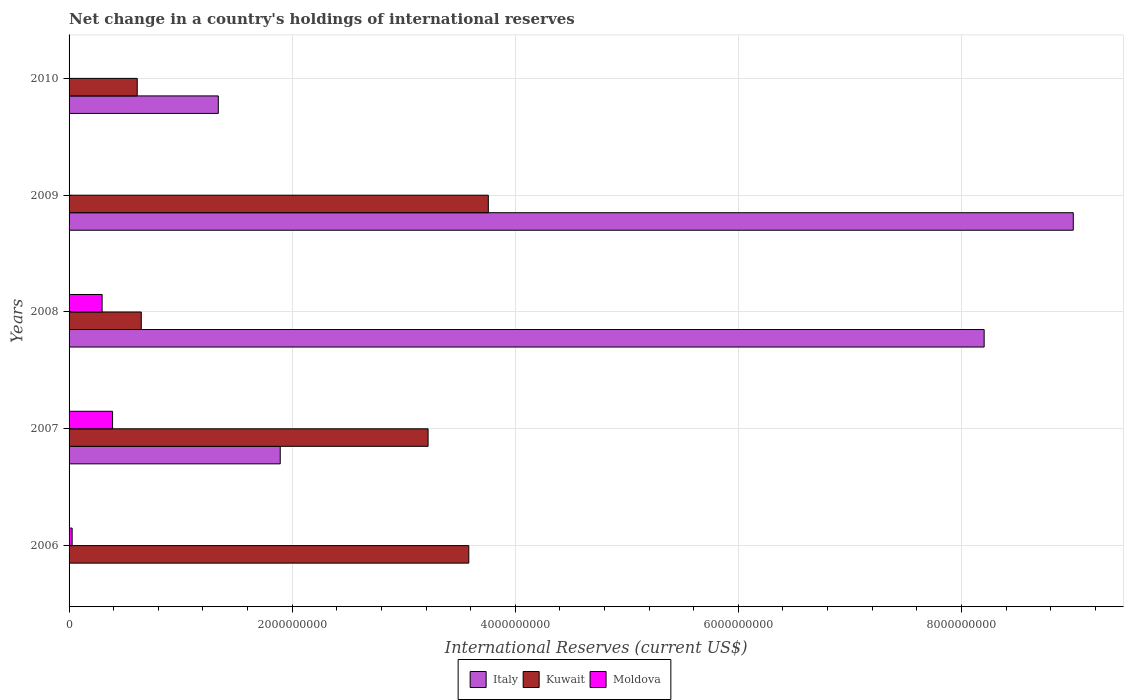How many different coloured bars are there?
Give a very brief answer. 3. How many groups of bars are there?
Offer a very short reply. 5. Are the number of bars per tick equal to the number of legend labels?
Your answer should be very brief. No. How many bars are there on the 3rd tick from the top?
Your response must be concise. 3. How many bars are there on the 1st tick from the bottom?
Ensure brevity in your answer.  2. What is the international reserves in Italy in 2010?
Your answer should be compact. 1.34e+09. Across all years, what is the maximum international reserves in Kuwait?
Your response must be concise. 3.76e+09. Across all years, what is the minimum international reserves in Italy?
Offer a very short reply. 0. In which year was the international reserves in Moldova maximum?
Offer a terse response. 2007. What is the total international reserves in Moldova in the graph?
Provide a short and direct response. 7.14e+08. What is the difference between the international reserves in Kuwait in 2006 and that in 2007?
Keep it short and to the point. 3.65e+08. What is the difference between the international reserves in Kuwait in 2010 and the international reserves in Italy in 2009?
Make the answer very short. -8.39e+09. What is the average international reserves in Kuwait per year?
Provide a short and direct response. 2.36e+09. In the year 2007, what is the difference between the international reserves in Kuwait and international reserves in Moldova?
Your answer should be compact. 2.83e+09. In how many years, is the international reserves in Kuwait greater than 1200000000 US$?
Offer a terse response. 3. What is the ratio of the international reserves in Italy in 2007 to that in 2010?
Give a very brief answer. 1.41. What is the difference between the highest and the second highest international reserves in Kuwait?
Ensure brevity in your answer.  1.75e+08. What is the difference between the highest and the lowest international reserves in Kuwait?
Provide a short and direct response. 3.15e+09. Is it the case that in every year, the sum of the international reserves in Moldova and international reserves in Italy is greater than the international reserves in Kuwait?
Your answer should be compact. No. How many bars are there?
Keep it short and to the point. 12. Are all the bars in the graph horizontal?
Ensure brevity in your answer.  Yes. What is the difference between two consecutive major ticks on the X-axis?
Give a very brief answer. 2.00e+09. Are the values on the major ticks of X-axis written in scientific E-notation?
Provide a succinct answer. No. Does the graph contain grids?
Make the answer very short. Yes. Where does the legend appear in the graph?
Make the answer very short. Bottom center. How are the legend labels stacked?
Offer a very short reply. Horizontal. What is the title of the graph?
Ensure brevity in your answer.  Net change in a country's holdings of international reserves. What is the label or title of the X-axis?
Offer a terse response. International Reserves (current US$). What is the label or title of the Y-axis?
Provide a succinct answer. Years. What is the International Reserves (current US$) in Italy in 2006?
Make the answer very short. 0. What is the International Reserves (current US$) of Kuwait in 2006?
Offer a very short reply. 3.58e+09. What is the International Reserves (current US$) of Moldova in 2006?
Provide a short and direct response. 2.75e+07. What is the International Reserves (current US$) in Italy in 2007?
Offer a very short reply. 1.89e+09. What is the International Reserves (current US$) of Kuwait in 2007?
Your answer should be compact. 3.22e+09. What is the International Reserves (current US$) in Moldova in 2007?
Your answer should be compact. 3.90e+08. What is the International Reserves (current US$) of Italy in 2008?
Give a very brief answer. 8.20e+09. What is the International Reserves (current US$) in Kuwait in 2008?
Give a very brief answer. 6.47e+08. What is the International Reserves (current US$) in Moldova in 2008?
Provide a succinct answer. 2.96e+08. What is the International Reserves (current US$) in Italy in 2009?
Your answer should be compact. 9.00e+09. What is the International Reserves (current US$) of Kuwait in 2009?
Offer a terse response. 3.76e+09. What is the International Reserves (current US$) of Italy in 2010?
Offer a very short reply. 1.34e+09. What is the International Reserves (current US$) of Kuwait in 2010?
Your response must be concise. 6.11e+08. What is the International Reserves (current US$) in Moldova in 2010?
Your response must be concise. 0. Across all years, what is the maximum International Reserves (current US$) of Italy?
Provide a succinct answer. 9.00e+09. Across all years, what is the maximum International Reserves (current US$) of Kuwait?
Give a very brief answer. 3.76e+09. Across all years, what is the maximum International Reserves (current US$) of Moldova?
Make the answer very short. 3.90e+08. Across all years, what is the minimum International Reserves (current US$) of Italy?
Ensure brevity in your answer.  0. Across all years, what is the minimum International Reserves (current US$) of Kuwait?
Offer a terse response. 6.11e+08. What is the total International Reserves (current US$) of Italy in the graph?
Offer a terse response. 2.04e+1. What is the total International Reserves (current US$) of Kuwait in the graph?
Give a very brief answer. 1.18e+1. What is the total International Reserves (current US$) of Moldova in the graph?
Offer a terse response. 7.14e+08. What is the difference between the International Reserves (current US$) of Kuwait in 2006 and that in 2007?
Make the answer very short. 3.65e+08. What is the difference between the International Reserves (current US$) in Moldova in 2006 and that in 2007?
Your answer should be very brief. -3.62e+08. What is the difference between the International Reserves (current US$) of Kuwait in 2006 and that in 2008?
Make the answer very short. 2.94e+09. What is the difference between the International Reserves (current US$) in Moldova in 2006 and that in 2008?
Provide a short and direct response. -2.69e+08. What is the difference between the International Reserves (current US$) in Kuwait in 2006 and that in 2009?
Offer a very short reply. -1.75e+08. What is the difference between the International Reserves (current US$) in Kuwait in 2006 and that in 2010?
Make the answer very short. 2.97e+09. What is the difference between the International Reserves (current US$) in Italy in 2007 and that in 2008?
Provide a succinct answer. -6.31e+09. What is the difference between the International Reserves (current US$) in Kuwait in 2007 and that in 2008?
Provide a short and direct response. 2.57e+09. What is the difference between the International Reserves (current US$) of Moldova in 2007 and that in 2008?
Keep it short and to the point. 9.37e+07. What is the difference between the International Reserves (current US$) in Italy in 2007 and that in 2009?
Keep it short and to the point. -7.11e+09. What is the difference between the International Reserves (current US$) of Kuwait in 2007 and that in 2009?
Give a very brief answer. -5.40e+08. What is the difference between the International Reserves (current US$) in Italy in 2007 and that in 2010?
Provide a short and direct response. 5.55e+08. What is the difference between the International Reserves (current US$) of Kuwait in 2007 and that in 2010?
Your answer should be very brief. 2.61e+09. What is the difference between the International Reserves (current US$) of Italy in 2008 and that in 2009?
Give a very brief answer. -7.99e+08. What is the difference between the International Reserves (current US$) of Kuwait in 2008 and that in 2009?
Your answer should be very brief. -3.11e+09. What is the difference between the International Reserves (current US$) in Italy in 2008 and that in 2010?
Provide a short and direct response. 6.87e+09. What is the difference between the International Reserves (current US$) of Kuwait in 2008 and that in 2010?
Offer a terse response. 3.63e+07. What is the difference between the International Reserves (current US$) in Italy in 2009 and that in 2010?
Provide a short and direct response. 7.66e+09. What is the difference between the International Reserves (current US$) of Kuwait in 2009 and that in 2010?
Ensure brevity in your answer.  3.15e+09. What is the difference between the International Reserves (current US$) of Kuwait in 2006 and the International Reserves (current US$) of Moldova in 2007?
Ensure brevity in your answer.  3.19e+09. What is the difference between the International Reserves (current US$) in Kuwait in 2006 and the International Reserves (current US$) in Moldova in 2008?
Your answer should be very brief. 3.29e+09. What is the difference between the International Reserves (current US$) in Italy in 2007 and the International Reserves (current US$) in Kuwait in 2008?
Your answer should be very brief. 1.25e+09. What is the difference between the International Reserves (current US$) in Italy in 2007 and the International Reserves (current US$) in Moldova in 2008?
Make the answer very short. 1.60e+09. What is the difference between the International Reserves (current US$) in Kuwait in 2007 and the International Reserves (current US$) in Moldova in 2008?
Provide a short and direct response. 2.92e+09. What is the difference between the International Reserves (current US$) in Italy in 2007 and the International Reserves (current US$) in Kuwait in 2009?
Make the answer very short. -1.87e+09. What is the difference between the International Reserves (current US$) of Italy in 2007 and the International Reserves (current US$) of Kuwait in 2010?
Your response must be concise. 1.28e+09. What is the difference between the International Reserves (current US$) in Italy in 2008 and the International Reserves (current US$) in Kuwait in 2009?
Make the answer very short. 4.45e+09. What is the difference between the International Reserves (current US$) in Italy in 2008 and the International Reserves (current US$) in Kuwait in 2010?
Keep it short and to the point. 7.59e+09. What is the difference between the International Reserves (current US$) of Italy in 2009 and the International Reserves (current US$) of Kuwait in 2010?
Your answer should be very brief. 8.39e+09. What is the average International Reserves (current US$) of Italy per year?
Give a very brief answer. 4.09e+09. What is the average International Reserves (current US$) of Kuwait per year?
Ensure brevity in your answer.  2.36e+09. What is the average International Reserves (current US$) of Moldova per year?
Make the answer very short. 1.43e+08. In the year 2006, what is the difference between the International Reserves (current US$) of Kuwait and International Reserves (current US$) of Moldova?
Give a very brief answer. 3.56e+09. In the year 2007, what is the difference between the International Reserves (current US$) of Italy and International Reserves (current US$) of Kuwait?
Your response must be concise. -1.33e+09. In the year 2007, what is the difference between the International Reserves (current US$) in Italy and International Reserves (current US$) in Moldova?
Provide a short and direct response. 1.50e+09. In the year 2007, what is the difference between the International Reserves (current US$) of Kuwait and International Reserves (current US$) of Moldova?
Provide a short and direct response. 2.83e+09. In the year 2008, what is the difference between the International Reserves (current US$) of Italy and International Reserves (current US$) of Kuwait?
Offer a terse response. 7.56e+09. In the year 2008, what is the difference between the International Reserves (current US$) in Italy and International Reserves (current US$) in Moldova?
Offer a very short reply. 7.91e+09. In the year 2008, what is the difference between the International Reserves (current US$) in Kuwait and International Reserves (current US$) in Moldova?
Keep it short and to the point. 3.51e+08. In the year 2009, what is the difference between the International Reserves (current US$) in Italy and International Reserves (current US$) in Kuwait?
Keep it short and to the point. 5.24e+09. In the year 2010, what is the difference between the International Reserves (current US$) of Italy and International Reserves (current US$) of Kuwait?
Make the answer very short. 7.27e+08. What is the ratio of the International Reserves (current US$) of Kuwait in 2006 to that in 2007?
Offer a very short reply. 1.11. What is the ratio of the International Reserves (current US$) in Moldova in 2006 to that in 2007?
Keep it short and to the point. 0.07. What is the ratio of the International Reserves (current US$) of Kuwait in 2006 to that in 2008?
Offer a very short reply. 5.54. What is the ratio of the International Reserves (current US$) in Moldova in 2006 to that in 2008?
Your answer should be compact. 0.09. What is the ratio of the International Reserves (current US$) of Kuwait in 2006 to that in 2009?
Your response must be concise. 0.95. What is the ratio of the International Reserves (current US$) in Kuwait in 2006 to that in 2010?
Provide a succinct answer. 5.86. What is the ratio of the International Reserves (current US$) in Italy in 2007 to that in 2008?
Provide a succinct answer. 0.23. What is the ratio of the International Reserves (current US$) of Kuwait in 2007 to that in 2008?
Your answer should be compact. 4.97. What is the ratio of the International Reserves (current US$) of Moldova in 2007 to that in 2008?
Keep it short and to the point. 1.32. What is the ratio of the International Reserves (current US$) in Italy in 2007 to that in 2009?
Ensure brevity in your answer.  0.21. What is the ratio of the International Reserves (current US$) of Kuwait in 2007 to that in 2009?
Offer a terse response. 0.86. What is the ratio of the International Reserves (current US$) in Italy in 2007 to that in 2010?
Provide a succinct answer. 1.42. What is the ratio of the International Reserves (current US$) of Kuwait in 2007 to that in 2010?
Make the answer very short. 5.27. What is the ratio of the International Reserves (current US$) of Italy in 2008 to that in 2009?
Ensure brevity in your answer.  0.91. What is the ratio of the International Reserves (current US$) in Kuwait in 2008 to that in 2009?
Make the answer very short. 0.17. What is the ratio of the International Reserves (current US$) in Italy in 2008 to that in 2010?
Give a very brief answer. 6.13. What is the ratio of the International Reserves (current US$) in Kuwait in 2008 to that in 2010?
Ensure brevity in your answer.  1.06. What is the ratio of the International Reserves (current US$) in Italy in 2009 to that in 2010?
Your response must be concise. 6.73. What is the ratio of the International Reserves (current US$) in Kuwait in 2009 to that in 2010?
Provide a succinct answer. 6.15. What is the difference between the highest and the second highest International Reserves (current US$) of Italy?
Your answer should be very brief. 7.99e+08. What is the difference between the highest and the second highest International Reserves (current US$) of Kuwait?
Your answer should be very brief. 1.75e+08. What is the difference between the highest and the second highest International Reserves (current US$) in Moldova?
Give a very brief answer. 9.37e+07. What is the difference between the highest and the lowest International Reserves (current US$) in Italy?
Keep it short and to the point. 9.00e+09. What is the difference between the highest and the lowest International Reserves (current US$) of Kuwait?
Your response must be concise. 3.15e+09. What is the difference between the highest and the lowest International Reserves (current US$) in Moldova?
Your answer should be very brief. 3.90e+08. 